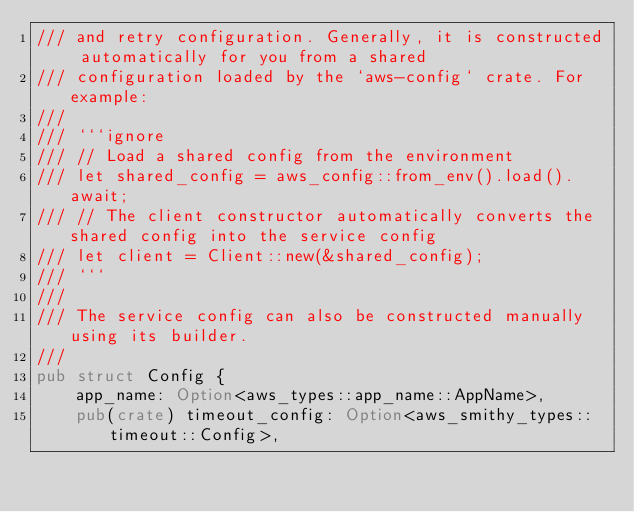<code> <loc_0><loc_0><loc_500><loc_500><_Rust_>/// and retry configuration. Generally, it is constructed automatically for you from a shared
/// configuration loaded by the `aws-config` crate. For example:
///
/// ```ignore
/// // Load a shared config from the environment
/// let shared_config = aws_config::from_env().load().await;
/// // The client constructor automatically converts the shared config into the service config
/// let client = Client::new(&shared_config);
/// ```
///
/// The service config can also be constructed manually using its builder.
///
pub struct Config {
    app_name: Option<aws_types::app_name::AppName>,
    pub(crate) timeout_config: Option<aws_smithy_types::timeout::Config>,</code> 